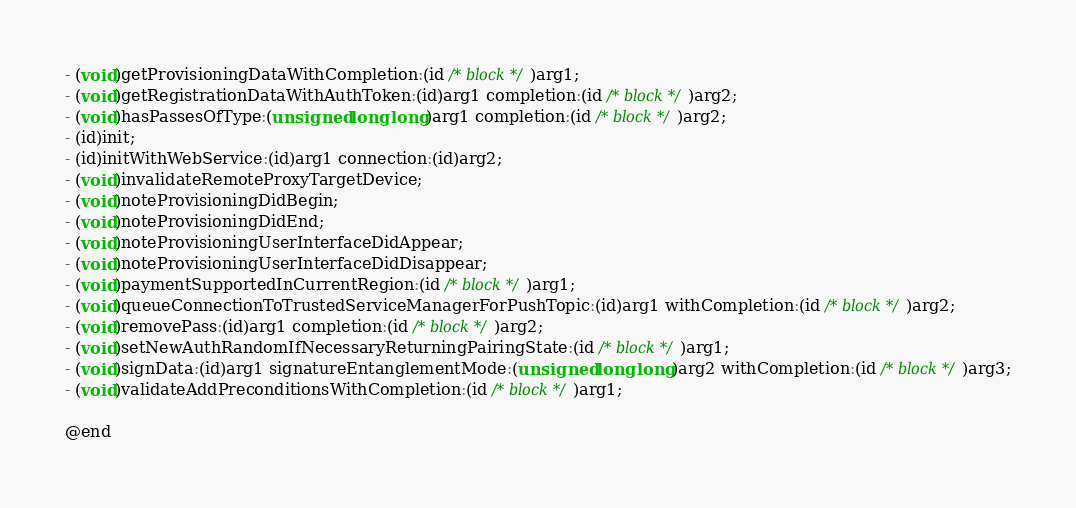<code> <loc_0><loc_0><loc_500><loc_500><_C_>- (void)getProvisioningDataWithCompletion:(id /* block */)arg1;
- (void)getRegistrationDataWithAuthToken:(id)arg1 completion:(id /* block */)arg2;
- (void)hasPassesOfType:(unsigned long long)arg1 completion:(id /* block */)arg2;
- (id)init;
- (id)initWithWebService:(id)arg1 connection:(id)arg2;
- (void)invalidateRemoteProxyTargetDevice;
- (void)noteProvisioningDidBegin;
- (void)noteProvisioningDidEnd;
- (void)noteProvisioningUserInterfaceDidAppear;
- (void)noteProvisioningUserInterfaceDidDisappear;
- (void)paymentSupportedInCurrentRegion:(id /* block */)arg1;
- (void)queueConnectionToTrustedServiceManagerForPushTopic:(id)arg1 withCompletion:(id /* block */)arg2;
- (void)removePass:(id)arg1 completion:(id /* block */)arg2;
- (void)setNewAuthRandomIfNecessaryReturningPairingState:(id /* block */)arg1;
- (void)signData:(id)arg1 signatureEntanglementMode:(unsigned long long)arg2 withCompletion:(id /* block */)arg3;
- (void)validateAddPreconditionsWithCompletion:(id /* block */)arg1;

@end
</code> 